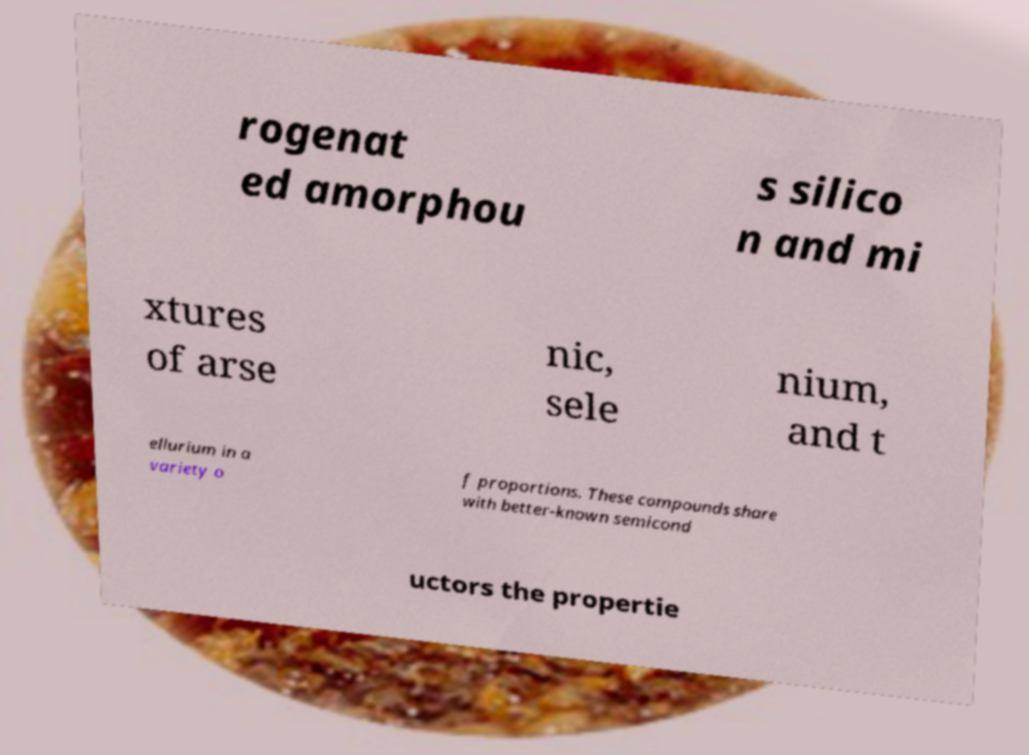Could you assist in decoding the text presented in this image and type it out clearly? rogenat ed amorphou s silico n and mi xtures of arse nic, sele nium, and t ellurium in a variety o f proportions. These compounds share with better-known semicond uctors the propertie 